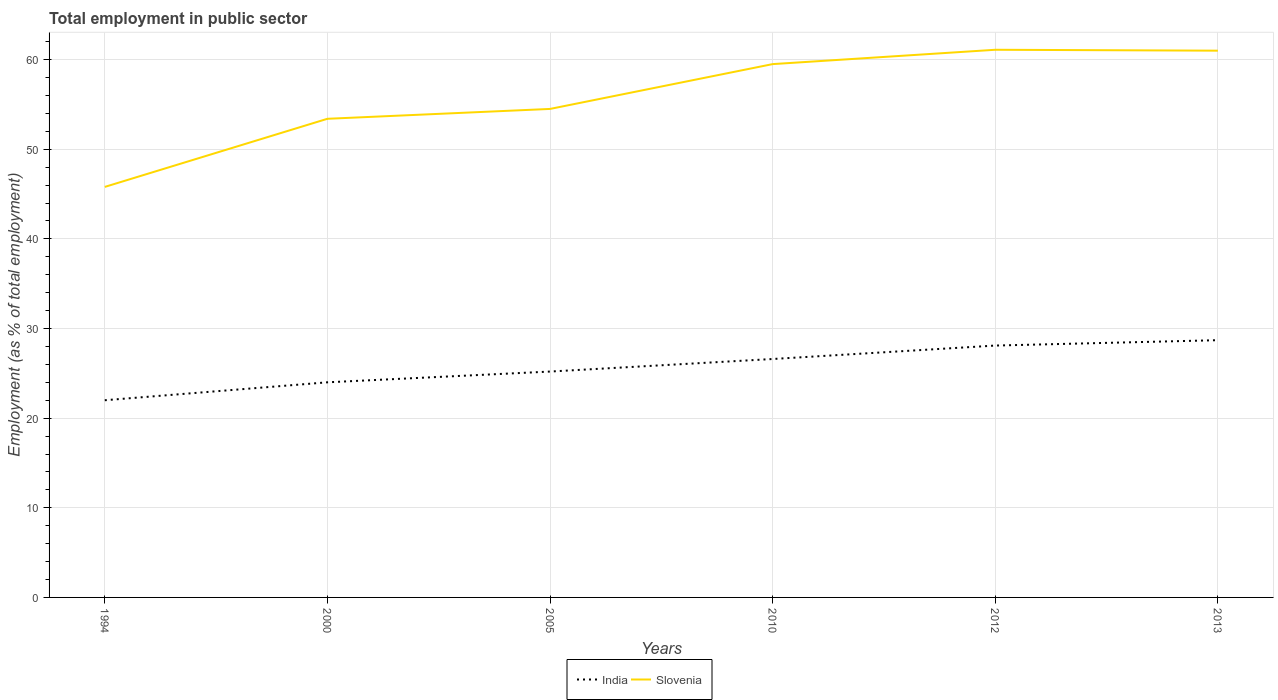How many different coloured lines are there?
Provide a succinct answer. 2. Does the line corresponding to India intersect with the line corresponding to Slovenia?
Your answer should be very brief. No. What is the total employment in public sector in Slovenia in the graph?
Make the answer very short. -13.7. What is the difference between the highest and the second highest employment in public sector in India?
Ensure brevity in your answer.  6.7. What is the difference between the highest and the lowest employment in public sector in India?
Offer a very short reply. 3. Is the employment in public sector in India strictly greater than the employment in public sector in Slovenia over the years?
Your answer should be compact. Yes. How many lines are there?
Your response must be concise. 2. What is the difference between two consecutive major ticks on the Y-axis?
Your response must be concise. 10. Does the graph contain any zero values?
Your answer should be compact. No. Where does the legend appear in the graph?
Offer a terse response. Bottom center. How many legend labels are there?
Make the answer very short. 2. How are the legend labels stacked?
Your response must be concise. Horizontal. What is the title of the graph?
Keep it short and to the point. Total employment in public sector. Does "Italy" appear as one of the legend labels in the graph?
Give a very brief answer. No. What is the label or title of the Y-axis?
Offer a terse response. Employment (as % of total employment). What is the Employment (as % of total employment) in India in 1994?
Provide a short and direct response. 22. What is the Employment (as % of total employment) in Slovenia in 1994?
Your response must be concise. 45.8. What is the Employment (as % of total employment) of India in 2000?
Give a very brief answer. 24. What is the Employment (as % of total employment) of Slovenia in 2000?
Your answer should be compact. 53.4. What is the Employment (as % of total employment) in India in 2005?
Give a very brief answer. 25.2. What is the Employment (as % of total employment) of Slovenia in 2005?
Keep it short and to the point. 54.5. What is the Employment (as % of total employment) of India in 2010?
Keep it short and to the point. 26.6. What is the Employment (as % of total employment) in Slovenia in 2010?
Ensure brevity in your answer.  59.5. What is the Employment (as % of total employment) in India in 2012?
Give a very brief answer. 28.1. What is the Employment (as % of total employment) of Slovenia in 2012?
Your answer should be compact. 61.1. What is the Employment (as % of total employment) of India in 2013?
Offer a very short reply. 28.7. What is the Employment (as % of total employment) in Slovenia in 2013?
Provide a succinct answer. 61. Across all years, what is the maximum Employment (as % of total employment) of India?
Make the answer very short. 28.7. Across all years, what is the maximum Employment (as % of total employment) in Slovenia?
Provide a succinct answer. 61.1. Across all years, what is the minimum Employment (as % of total employment) of Slovenia?
Offer a terse response. 45.8. What is the total Employment (as % of total employment) of India in the graph?
Offer a very short reply. 154.6. What is the total Employment (as % of total employment) of Slovenia in the graph?
Your answer should be compact. 335.3. What is the difference between the Employment (as % of total employment) in India in 1994 and that in 2000?
Keep it short and to the point. -2. What is the difference between the Employment (as % of total employment) in Slovenia in 1994 and that in 2000?
Ensure brevity in your answer.  -7.6. What is the difference between the Employment (as % of total employment) in Slovenia in 1994 and that in 2010?
Offer a terse response. -13.7. What is the difference between the Employment (as % of total employment) of India in 1994 and that in 2012?
Ensure brevity in your answer.  -6.1. What is the difference between the Employment (as % of total employment) in Slovenia in 1994 and that in 2012?
Provide a short and direct response. -15.3. What is the difference between the Employment (as % of total employment) in Slovenia in 1994 and that in 2013?
Keep it short and to the point. -15.2. What is the difference between the Employment (as % of total employment) of India in 2000 and that in 2005?
Make the answer very short. -1.2. What is the difference between the Employment (as % of total employment) in Slovenia in 2000 and that in 2012?
Your answer should be very brief. -7.7. What is the difference between the Employment (as % of total employment) in India in 2005 and that in 2010?
Your answer should be very brief. -1.4. What is the difference between the Employment (as % of total employment) in Slovenia in 2005 and that in 2012?
Offer a very short reply. -6.6. What is the difference between the Employment (as % of total employment) in India in 2005 and that in 2013?
Ensure brevity in your answer.  -3.5. What is the difference between the Employment (as % of total employment) of India in 2010 and that in 2013?
Make the answer very short. -2.1. What is the difference between the Employment (as % of total employment) in India in 1994 and the Employment (as % of total employment) in Slovenia in 2000?
Your answer should be very brief. -31.4. What is the difference between the Employment (as % of total employment) of India in 1994 and the Employment (as % of total employment) of Slovenia in 2005?
Provide a short and direct response. -32.5. What is the difference between the Employment (as % of total employment) in India in 1994 and the Employment (as % of total employment) in Slovenia in 2010?
Your response must be concise. -37.5. What is the difference between the Employment (as % of total employment) in India in 1994 and the Employment (as % of total employment) in Slovenia in 2012?
Offer a terse response. -39.1. What is the difference between the Employment (as % of total employment) in India in 1994 and the Employment (as % of total employment) in Slovenia in 2013?
Your response must be concise. -39. What is the difference between the Employment (as % of total employment) of India in 2000 and the Employment (as % of total employment) of Slovenia in 2005?
Provide a short and direct response. -30.5. What is the difference between the Employment (as % of total employment) of India in 2000 and the Employment (as % of total employment) of Slovenia in 2010?
Your response must be concise. -35.5. What is the difference between the Employment (as % of total employment) in India in 2000 and the Employment (as % of total employment) in Slovenia in 2012?
Ensure brevity in your answer.  -37.1. What is the difference between the Employment (as % of total employment) of India in 2000 and the Employment (as % of total employment) of Slovenia in 2013?
Your answer should be very brief. -37. What is the difference between the Employment (as % of total employment) of India in 2005 and the Employment (as % of total employment) of Slovenia in 2010?
Offer a very short reply. -34.3. What is the difference between the Employment (as % of total employment) of India in 2005 and the Employment (as % of total employment) of Slovenia in 2012?
Your answer should be very brief. -35.9. What is the difference between the Employment (as % of total employment) of India in 2005 and the Employment (as % of total employment) of Slovenia in 2013?
Provide a succinct answer. -35.8. What is the difference between the Employment (as % of total employment) of India in 2010 and the Employment (as % of total employment) of Slovenia in 2012?
Offer a terse response. -34.5. What is the difference between the Employment (as % of total employment) of India in 2010 and the Employment (as % of total employment) of Slovenia in 2013?
Your response must be concise. -34.4. What is the difference between the Employment (as % of total employment) in India in 2012 and the Employment (as % of total employment) in Slovenia in 2013?
Ensure brevity in your answer.  -32.9. What is the average Employment (as % of total employment) of India per year?
Offer a very short reply. 25.77. What is the average Employment (as % of total employment) in Slovenia per year?
Provide a short and direct response. 55.88. In the year 1994, what is the difference between the Employment (as % of total employment) in India and Employment (as % of total employment) in Slovenia?
Give a very brief answer. -23.8. In the year 2000, what is the difference between the Employment (as % of total employment) of India and Employment (as % of total employment) of Slovenia?
Offer a terse response. -29.4. In the year 2005, what is the difference between the Employment (as % of total employment) in India and Employment (as % of total employment) in Slovenia?
Your response must be concise. -29.3. In the year 2010, what is the difference between the Employment (as % of total employment) in India and Employment (as % of total employment) in Slovenia?
Give a very brief answer. -32.9. In the year 2012, what is the difference between the Employment (as % of total employment) in India and Employment (as % of total employment) in Slovenia?
Offer a very short reply. -33. In the year 2013, what is the difference between the Employment (as % of total employment) in India and Employment (as % of total employment) in Slovenia?
Make the answer very short. -32.3. What is the ratio of the Employment (as % of total employment) in India in 1994 to that in 2000?
Keep it short and to the point. 0.92. What is the ratio of the Employment (as % of total employment) of Slovenia in 1994 to that in 2000?
Give a very brief answer. 0.86. What is the ratio of the Employment (as % of total employment) of India in 1994 to that in 2005?
Your answer should be compact. 0.87. What is the ratio of the Employment (as % of total employment) of Slovenia in 1994 to that in 2005?
Offer a terse response. 0.84. What is the ratio of the Employment (as % of total employment) in India in 1994 to that in 2010?
Keep it short and to the point. 0.83. What is the ratio of the Employment (as % of total employment) in Slovenia in 1994 to that in 2010?
Make the answer very short. 0.77. What is the ratio of the Employment (as % of total employment) in India in 1994 to that in 2012?
Give a very brief answer. 0.78. What is the ratio of the Employment (as % of total employment) in Slovenia in 1994 to that in 2012?
Offer a very short reply. 0.75. What is the ratio of the Employment (as % of total employment) in India in 1994 to that in 2013?
Your answer should be very brief. 0.77. What is the ratio of the Employment (as % of total employment) in Slovenia in 1994 to that in 2013?
Provide a short and direct response. 0.75. What is the ratio of the Employment (as % of total employment) in Slovenia in 2000 to that in 2005?
Keep it short and to the point. 0.98. What is the ratio of the Employment (as % of total employment) in India in 2000 to that in 2010?
Provide a succinct answer. 0.9. What is the ratio of the Employment (as % of total employment) in Slovenia in 2000 to that in 2010?
Make the answer very short. 0.9. What is the ratio of the Employment (as % of total employment) in India in 2000 to that in 2012?
Offer a very short reply. 0.85. What is the ratio of the Employment (as % of total employment) of Slovenia in 2000 to that in 2012?
Your answer should be compact. 0.87. What is the ratio of the Employment (as % of total employment) in India in 2000 to that in 2013?
Provide a short and direct response. 0.84. What is the ratio of the Employment (as % of total employment) in Slovenia in 2000 to that in 2013?
Offer a very short reply. 0.88. What is the ratio of the Employment (as % of total employment) of India in 2005 to that in 2010?
Offer a terse response. 0.95. What is the ratio of the Employment (as % of total employment) in Slovenia in 2005 to that in 2010?
Keep it short and to the point. 0.92. What is the ratio of the Employment (as % of total employment) in India in 2005 to that in 2012?
Your response must be concise. 0.9. What is the ratio of the Employment (as % of total employment) of Slovenia in 2005 to that in 2012?
Provide a succinct answer. 0.89. What is the ratio of the Employment (as % of total employment) in India in 2005 to that in 2013?
Keep it short and to the point. 0.88. What is the ratio of the Employment (as % of total employment) of Slovenia in 2005 to that in 2013?
Your answer should be very brief. 0.89. What is the ratio of the Employment (as % of total employment) in India in 2010 to that in 2012?
Ensure brevity in your answer.  0.95. What is the ratio of the Employment (as % of total employment) in Slovenia in 2010 to that in 2012?
Offer a terse response. 0.97. What is the ratio of the Employment (as % of total employment) of India in 2010 to that in 2013?
Your answer should be compact. 0.93. What is the ratio of the Employment (as % of total employment) in Slovenia in 2010 to that in 2013?
Give a very brief answer. 0.98. What is the ratio of the Employment (as % of total employment) in India in 2012 to that in 2013?
Your answer should be very brief. 0.98. What is the ratio of the Employment (as % of total employment) in Slovenia in 2012 to that in 2013?
Provide a succinct answer. 1. What is the difference between the highest and the second highest Employment (as % of total employment) of Slovenia?
Ensure brevity in your answer.  0.1. What is the difference between the highest and the lowest Employment (as % of total employment) in India?
Offer a terse response. 6.7. 